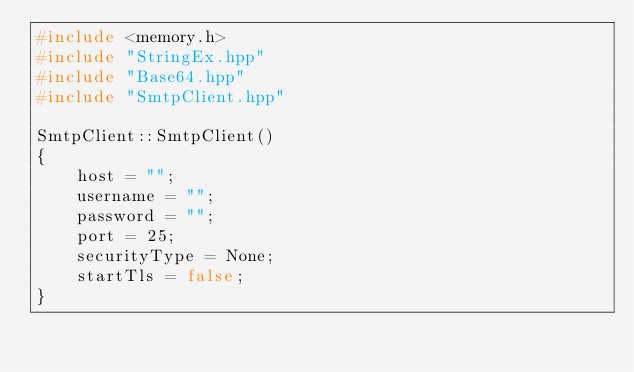Convert code to text. <code><loc_0><loc_0><loc_500><loc_500><_C++_>#include <memory.h>
#include "StringEx.hpp"
#include "Base64.hpp"
#include "SmtpClient.hpp"

SmtpClient::SmtpClient()
{
	host = "";
	username = "";
	password = "";
	port = 25;
	securityType = None;
	startTls = false;
}
</code> 